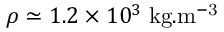Convert formula to latex. <formula><loc_0><loc_0><loc_500><loc_500>\rho \simeq 1 . 2 \times 1 0 ^ { 3 } \, { k g . m ^ { - 3 } }</formula> 